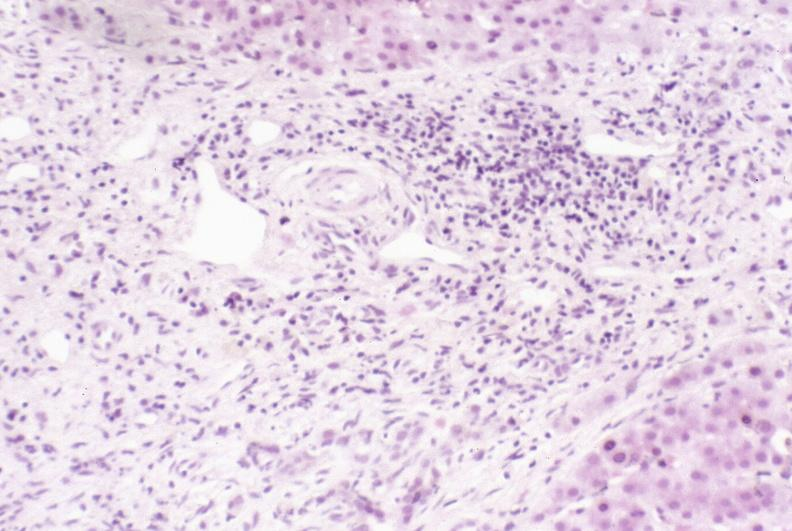what is present?
Answer the question using a single word or phrase. Hepatobiliary 